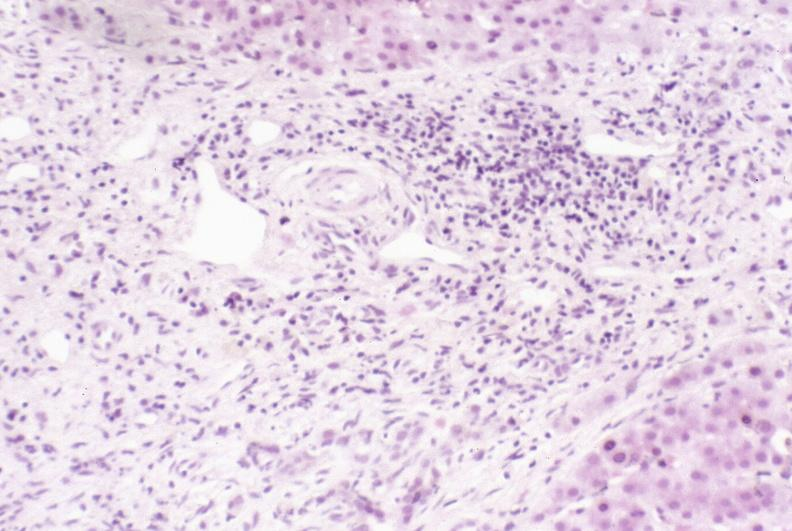what is present?
Answer the question using a single word or phrase. Hepatobiliary 